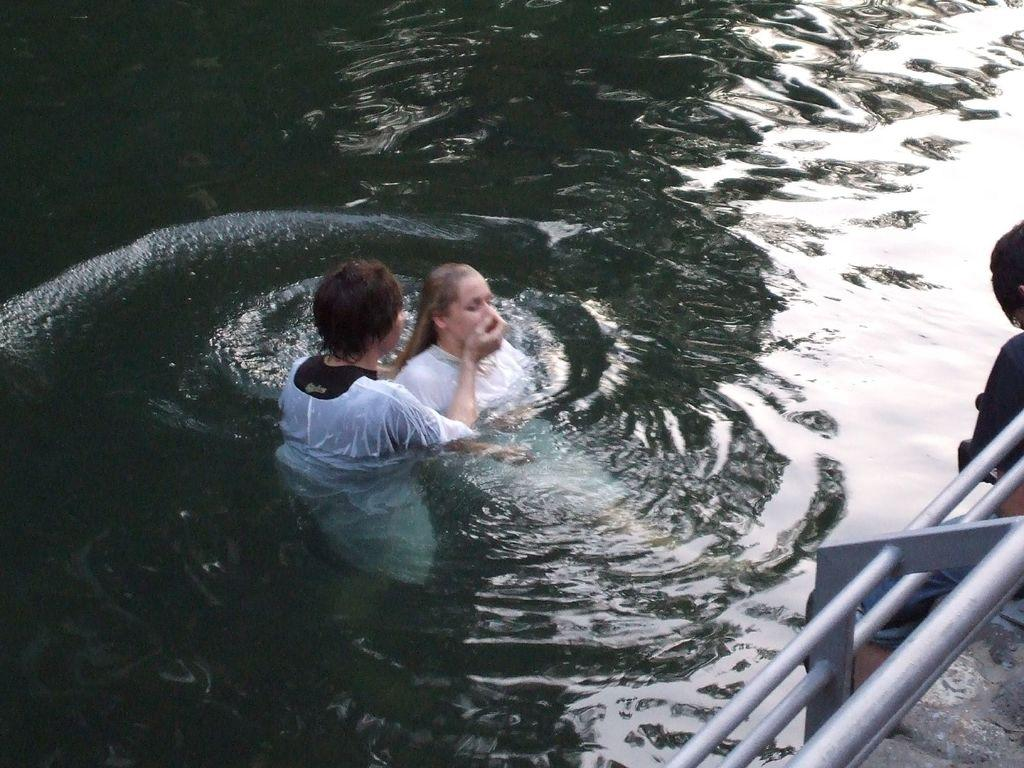How many people are in the image? There are three persons in the image. What are the persons doing in the image? The persons are in the water. What other object can be seen in the image? There is a fence in the image. Where might this image have been taken? The image may have been taken in a swimming pool, given that the persons are in the water. What type of committee is visible in the image? There is no committee present in the image. Can you see any hands in the image? The image does not show any hands; it only shows three persons in the water and a fence. 